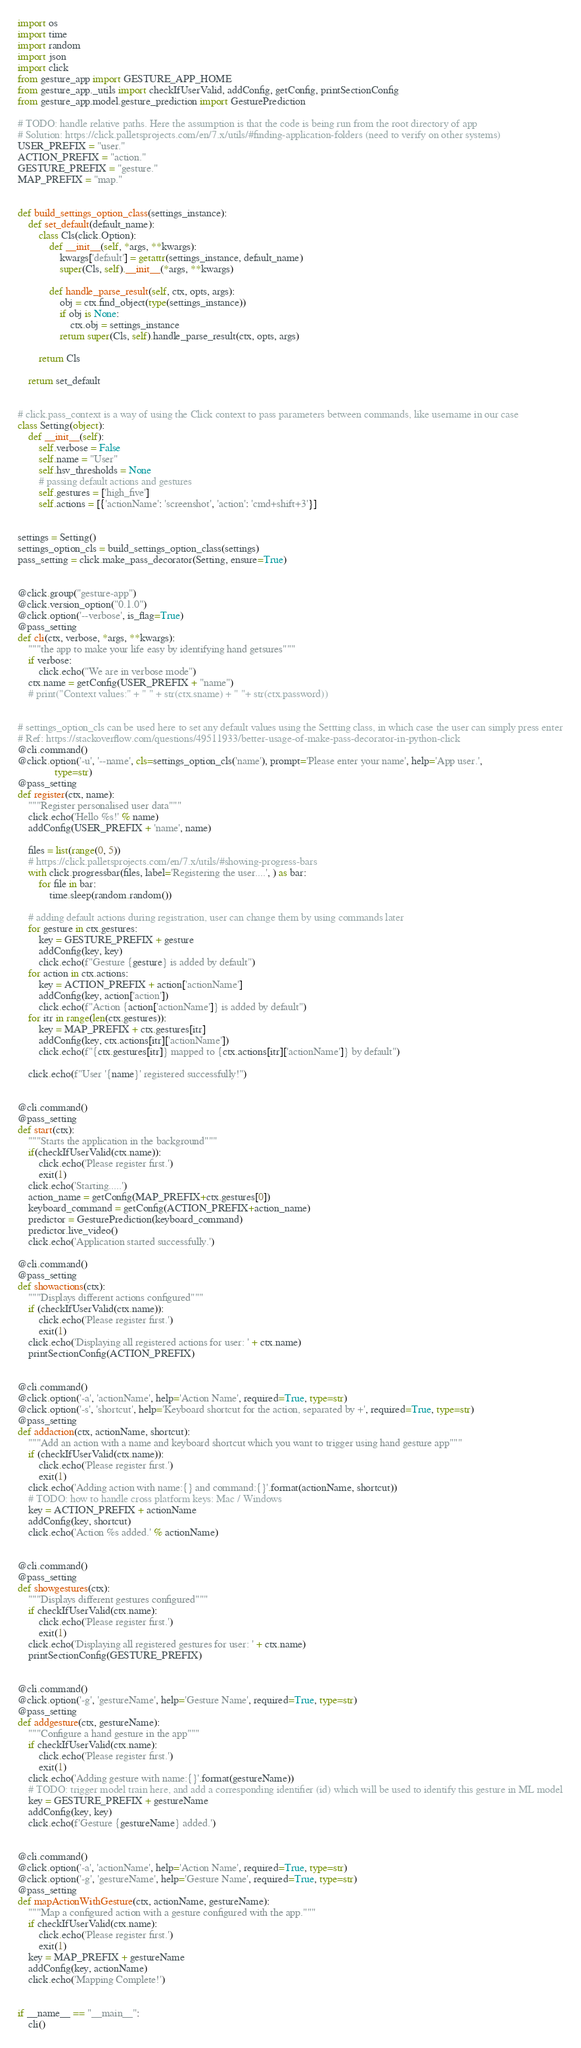<code> <loc_0><loc_0><loc_500><loc_500><_Python_>import os
import time
import random
import json
import click
from gesture_app import GESTURE_APP_HOME
from gesture_app._utils import checkIfUserValid, addConfig, getConfig, printSectionConfig
from gesture_app.model.gesture_prediction import GesturePrediction

# TODO: handle relative paths. Here the assumption is that the code is being run from the root directory of app
# Solution: https://click.palletsprojects.com/en/7.x/utils/#finding-application-folders (need to verify on other systems)
USER_PREFIX = "user."
ACTION_PREFIX = "action."
GESTURE_PREFIX = "gesture."
MAP_PREFIX = "map."


def build_settings_option_class(settings_instance):
    def set_default(default_name):
        class Cls(click.Option):
            def __init__(self, *args, **kwargs):
                kwargs['default'] = getattr(settings_instance, default_name)
                super(Cls, self).__init__(*args, **kwargs)

            def handle_parse_result(self, ctx, opts, args):
                obj = ctx.find_object(type(settings_instance))
                if obj is None:
                    ctx.obj = settings_instance
                return super(Cls, self).handle_parse_result(ctx, opts, args)

        return Cls

    return set_default


# click.pass_context is a way of using the Click context to pass parameters between commands, like username in our case
class Setting(object):
    def __init__(self):
        self.verbose = False
        self.name = "User"
        self.hsv_thresholds = None
        # passing default actions and gestures
        self.gestures = ['high_five']
        self.actions = [{'actionName': 'screenshot', 'action': 'cmd+shift+3'}]


settings = Setting()
settings_option_cls = build_settings_option_class(settings)
pass_setting = click.make_pass_decorator(Setting, ensure=True)


@click.group("gesture-app")
@click.version_option("0.1.0")
@click.option('--verbose', is_flag=True)
@pass_setting
def cli(ctx, verbose, *args, **kwargs):
    """the app to make your life easy by identifying hand getsures"""
    if verbose:
        click.echo("We are in verbose mode")
    ctx.name = getConfig(USER_PREFIX + "name")
    # print("Context values:" + " " + str(ctx.sname) + " "+ str(ctx.password))


# settings_option_cls can be used here to set any default values using the Settting class, in which case the user can simply press enter
# Ref: https://stackoverflow.com/questions/49511933/better-usage-of-make-pass-decorator-in-python-click
@cli.command()
@click.option('-u', '--name', cls=settings_option_cls('name'), prompt='Please enter your name', help='App user.',
              type=str)
@pass_setting
def register(ctx, name):
    """Register personalised user data"""
    click.echo('Hello %s!' % name)
    addConfig(USER_PREFIX + 'name', name)

    files = list(range(0, 5))
    # https://click.palletsprojects.com/en/7.x/utils/#showing-progress-bars
    with click.progressbar(files, label='Registering the user....', ) as bar:
        for file in bar:
            time.sleep(random.random())

    # adding default actions during registration, user can change them by using commands later
    for gesture in ctx.gestures:
        key = GESTURE_PREFIX + gesture
        addConfig(key, key)
        click.echo(f"Gesture {gesture} is added by default")
    for action in ctx.actions:
        key = ACTION_PREFIX + action['actionName']
        addConfig(key, action['action'])
        click.echo(f"Action {action['actionName']} is added by default")
    for itr in range(len(ctx.gestures)):
        key = MAP_PREFIX + ctx.gestures[itr]
        addConfig(key, ctx.actions[itr]['actionName'])
        click.echo(f"{ctx.gestures[itr]} mapped to {ctx.actions[itr]['actionName']} by default")

    click.echo(f"User '{name}' registered successfully!")


@cli.command()
@pass_setting
def start(ctx):
    """Starts the application in the background"""
    if(checkIfUserValid(ctx.name)):
        click.echo('Please register first.')
        exit(1)
    click.echo('Starting.....')
    action_name = getConfig(MAP_PREFIX+ctx.gestures[0])
    keyboard_command = getConfig(ACTION_PREFIX+action_name)
    predictor = GesturePrediction(keyboard_command)
    predictor.live_video()
    click.echo('Application started successfully.')

@cli.command()
@pass_setting
def showactions(ctx):
    """Displays different actions configured"""
    if (checkIfUserValid(ctx.name)):
        click.echo('Please register first.')
        exit(1)
    click.echo('Displaying all registered actions for user: ' + ctx.name)
    printSectionConfig(ACTION_PREFIX)


@cli.command()
@click.option('-a', 'actionName', help='Action Name', required=True, type=str)
@click.option('-s', 'shortcut', help='Keyboard shortcut for the action, separated by +', required=True, type=str)
@pass_setting
def addaction(ctx, actionName, shortcut):
    """Add an action with a name and keyboard shortcut which you want to trigger using hand gesture app"""
    if (checkIfUserValid(ctx.name)):
        click.echo('Please register first.')
        exit(1)
    click.echo('Adding action with name:{} and command:{}'.format(actionName, shortcut))
    # TODO: how to handle cross platform keys: Mac / Windows
    key = ACTION_PREFIX + actionName
    addConfig(key, shortcut)
    click.echo('Action %s added.' % actionName)


@cli.command()
@pass_setting
def showgestures(ctx):
    """Displays different gestures configured"""
    if checkIfUserValid(ctx.name):
        click.echo('Please register first.')
        exit(1)
    click.echo('Displaying all registered gestures for user: ' + ctx.name)
    printSectionConfig(GESTURE_PREFIX)


@cli.command()
@click.option('-g', 'gestureName', help='Gesture Name', required=True, type=str)
@pass_setting
def addgesture(ctx, gestureName):
    """Configure a hand gesture in the app"""
    if checkIfUserValid(ctx.name):
        click.echo('Please register first.')
        exit(1)
    click.echo('Adding gesture with name:{}'.format(gestureName))
    # TODO: trigger model train here, and add a corresponding identifier (id) which will be used to identify this gesture in ML model
    key = GESTURE_PREFIX + gestureName
    addConfig(key, key)
    click.echo(f'Gesture {gestureName} added.')


@cli.command()
@click.option('-a', 'actionName', help='Action Name', required=True, type=str)
@click.option('-g', 'gestureName', help='Gesture Name', required=True, type=str)
@pass_setting
def mapActionWithGesture(ctx, actionName, gestureName):
    """Map a configured action with a gesture configured with the app."""
    if checkIfUserValid(ctx.name):
        click.echo('Please register first.')
        exit(1)
    key = MAP_PREFIX + gestureName
    addConfig(key, actionName)
    click.echo('Mapping Complete!')


if __name__ == "__main__":
    cli()
</code> 